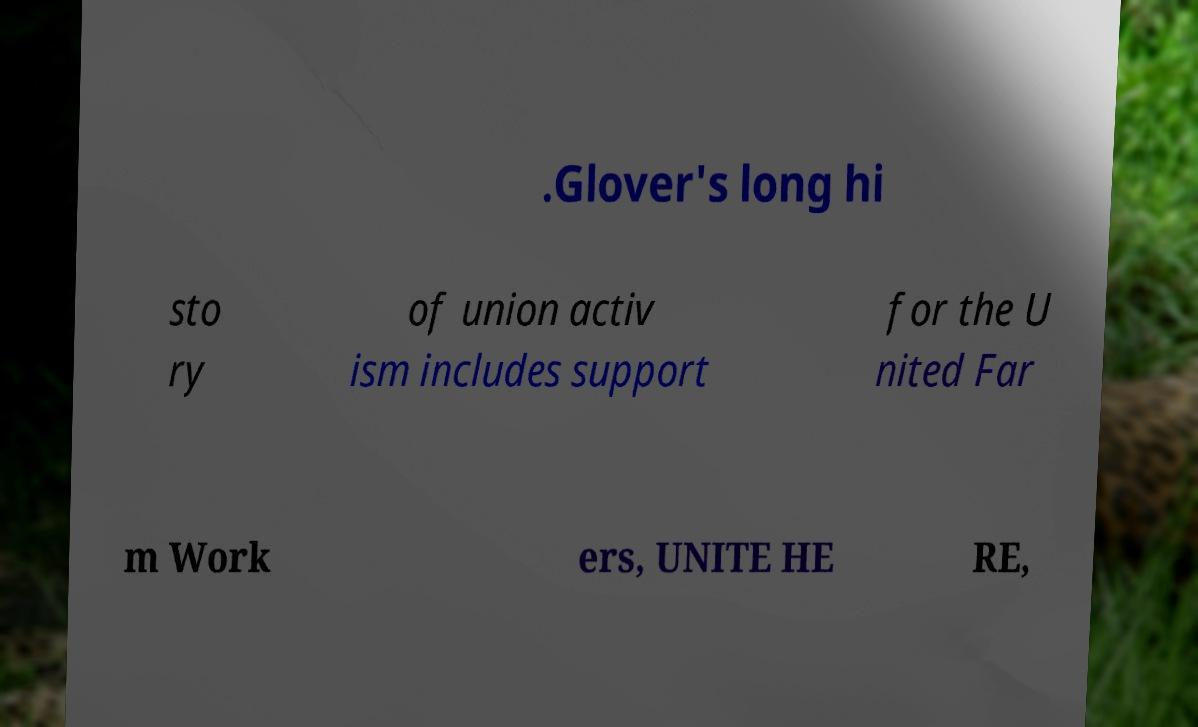What messages or text are displayed in this image? I need them in a readable, typed format. .Glover's long hi sto ry of union activ ism includes support for the U nited Far m Work ers, UNITE HE RE, 